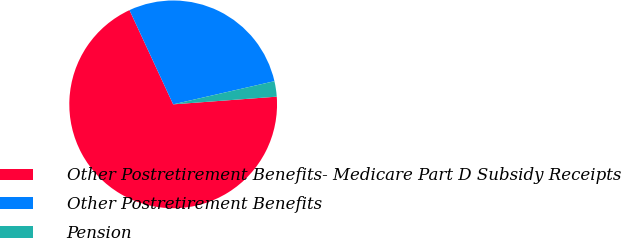Convert chart. <chart><loc_0><loc_0><loc_500><loc_500><pie_chart><fcel>Other Postretirement Benefits- Medicare Part D Subsidy Receipts<fcel>Other Postretirement Benefits<fcel>Pension<nl><fcel>69.27%<fcel>28.33%<fcel>2.4%<nl></chart> 